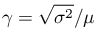<formula> <loc_0><loc_0><loc_500><loc_500>\gamma = { \sqrt { \sigma ^ { 2 } } } / \mu</formula> 